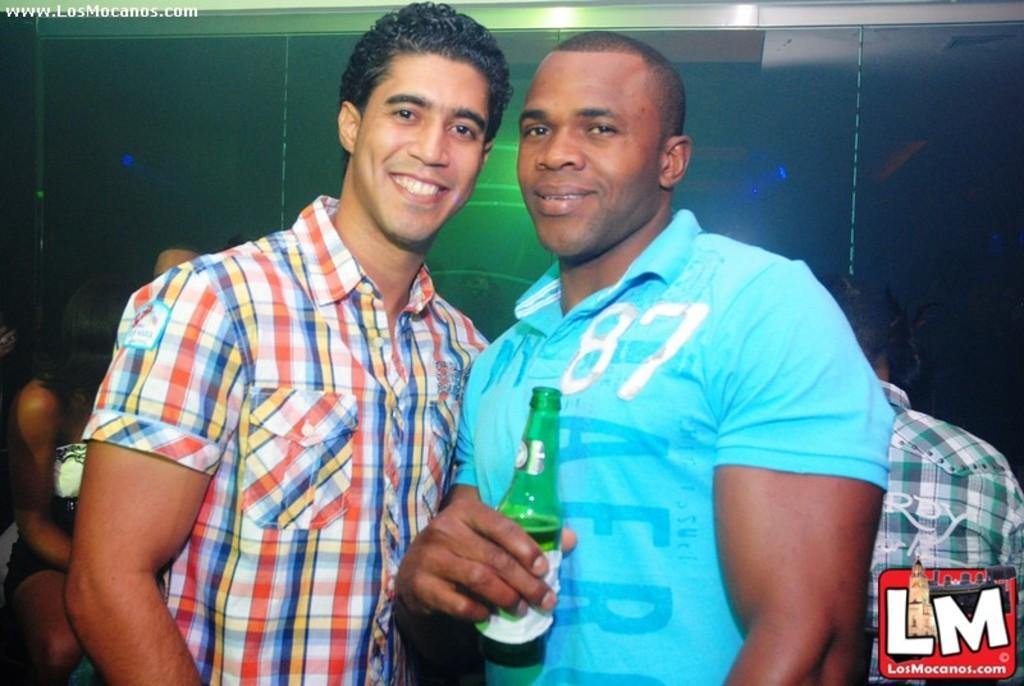How many people are in the image? There are two persons standing in the image. What are the expressions on their faces? Both persons are smiling. What is one person holding in the image? One person is holding a bottle. What can be seen in the background of the image? There is a wall in the background of the image. What type of marble is visible on the ground in the image? There is no marble visible on the ground in the image. How many ants can be seen crawling on the person holding the bottle? There are no ants present in the image. Is there a seat available for the second person in the image? The provided facts do not mention a seat or seating arrangement, so it cannot be determined from the image. 